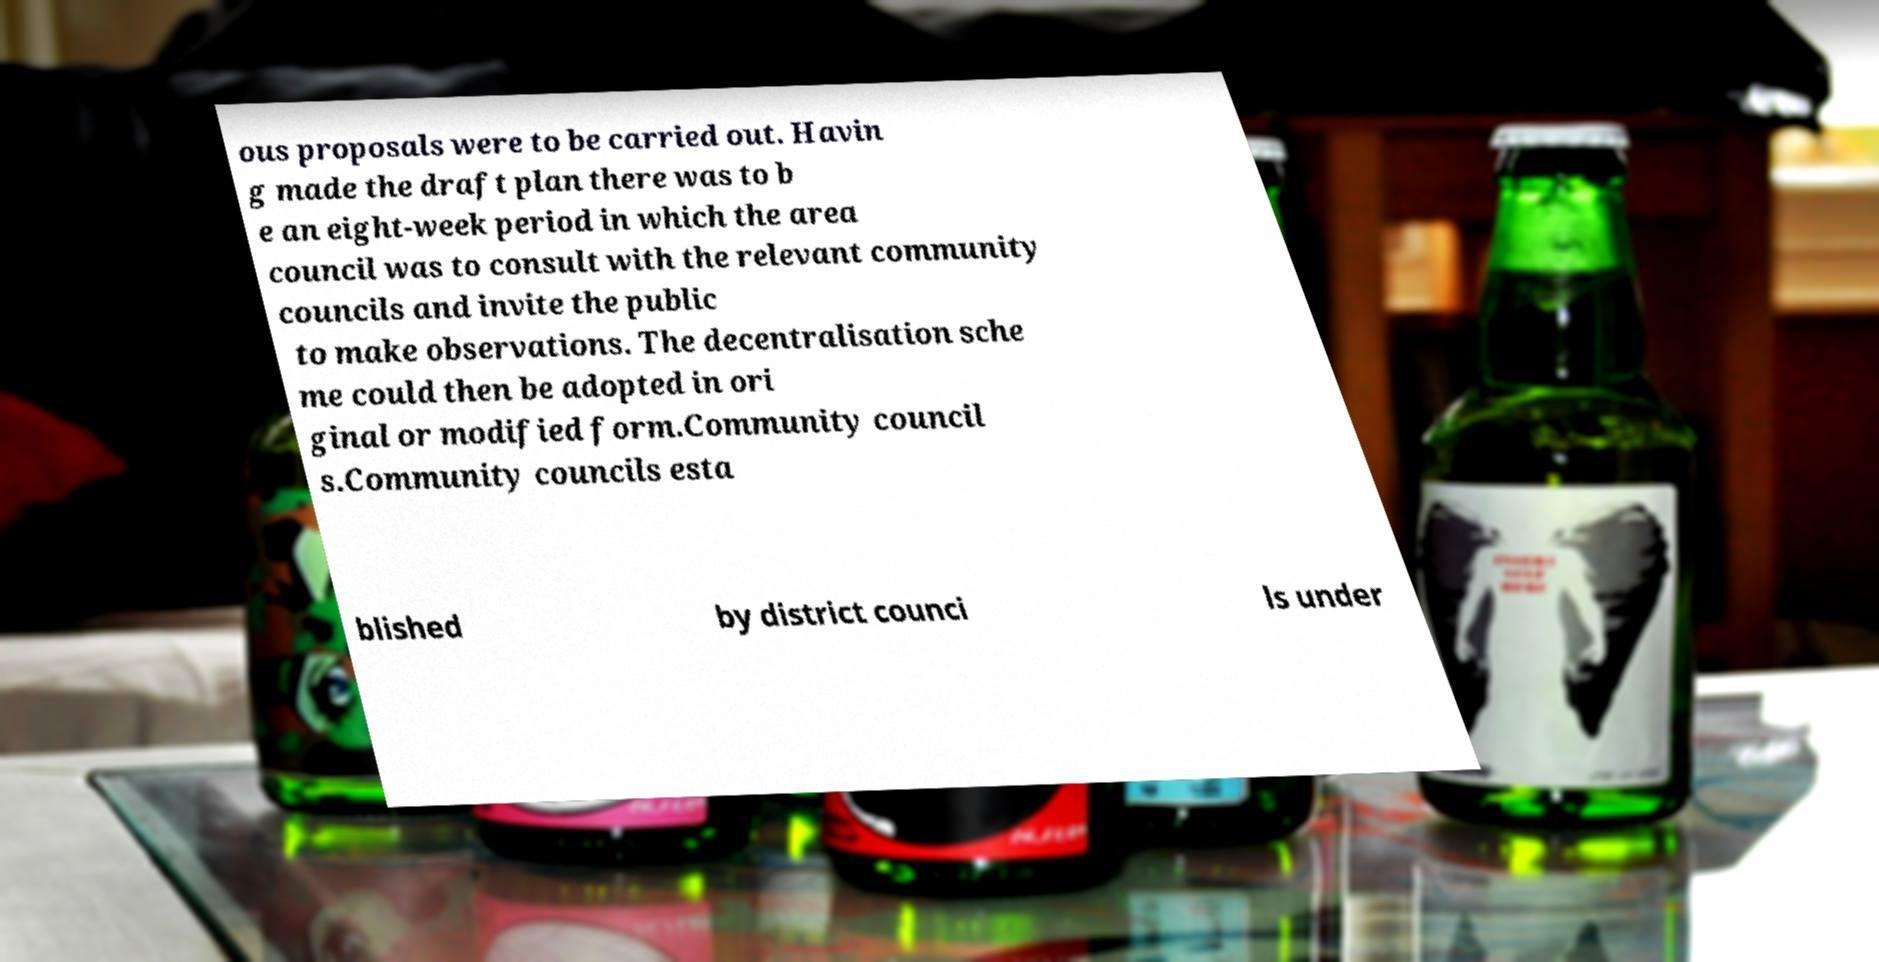Can you accurately transcribe the text from the provided image for me? ous proposals were to be carried out. Havin g made the draft plan there was to b e an eight-week period in which the area council was to consult with the relevant community councils and invite the public to make observations. The decentralisation sche me could then be adopted in ori ginal or modified form.Community council s.Community councils esta blished by district counci ls under 